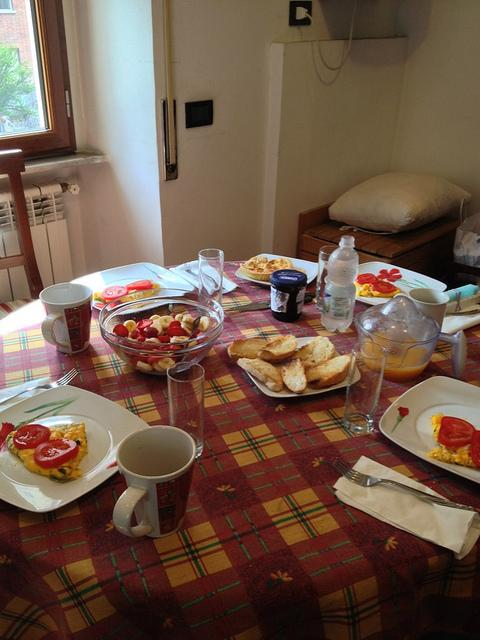What will they serve to drink? Please explain your reasoning. orange juice. The eggs on their plates indicate they are likely eating breakfast, and orange juice is a popular breakfast drink. an orange liquid can also be seen in a jug on the table. 